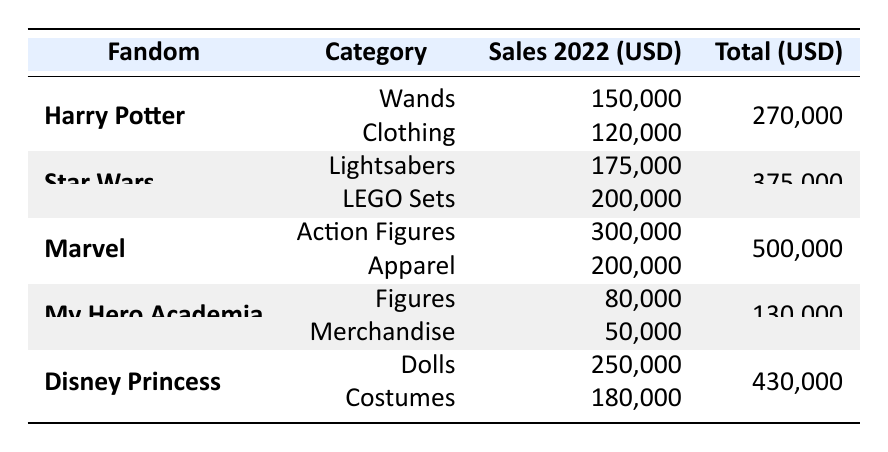What is the total sales for the Marvel fandom? The total sales for the Marvel fandom are listed in the table as 500,000 USD.
Answer: 500,000 USD Which category under Star Wars had the highest sales in 2022? According to the table, the LEGO Sets category had sales of 200,000 USD, which is higher than the Lightsabers category's 175,000 USD.
Answer: LEGO Sets What is the total sales for Harry Potter merchandise? The total sales for Harry Potter is the sum of its two categories: 150,000 USD (Wands) + 120,000 USD (Clothing) = 270,000 USD.
Answer: 270,000 USD Which fandom had the lowest sales overall? My Hero Academia had the lowest total sales with 130,000 USD, compared to the others listed.
Answer: My Hero Academia Did the Disney Princess fandom have higher sales than the Marvel fandom? The total sales for Disney Princess is 430,000 USD, which is lower than Marvel's 500,000 USD, so the answer is no.
Answer: No What is the difference in total sales between Star Wars and Disney Princess? Star Wars total sales are 375,000 USD, and Disney Princess total sales are 430,000 USD. The difference is 430,000 - 375,000 = 55,000 USD.
Answer: 55,000 USD Which category of merchandise for My Hero Academia had the least sales? My Hero Academia had two categories: Figures with 80,000 USD and Merchandise with 50,000 USD. Merchandise had the least sales.
Answer: Merchandise What is the average sales across all categories for the Harry Potter fandom? The average is calculated by taking total sales (270,000 USD) and dividing it by the number of categories (2): 270,000 / 2 = 135,000 USD.
Answer: 135,000 USD If we combine the sales of all fandoms, which fandom contributes the most to the total? Marvel contributes the most with a total of 500,000 USD, which is higher than the totals of the other fandoms.
Answer: Marvel Which fandom has a total sales amount that is an even number? All fandoms' total sales amounts are even: Harry Potter (270,000), Star Wars (375,000), Marvel (500,000), My Hero Academia (130,000), and Disney Princess (430,000).
Answer: All of them 